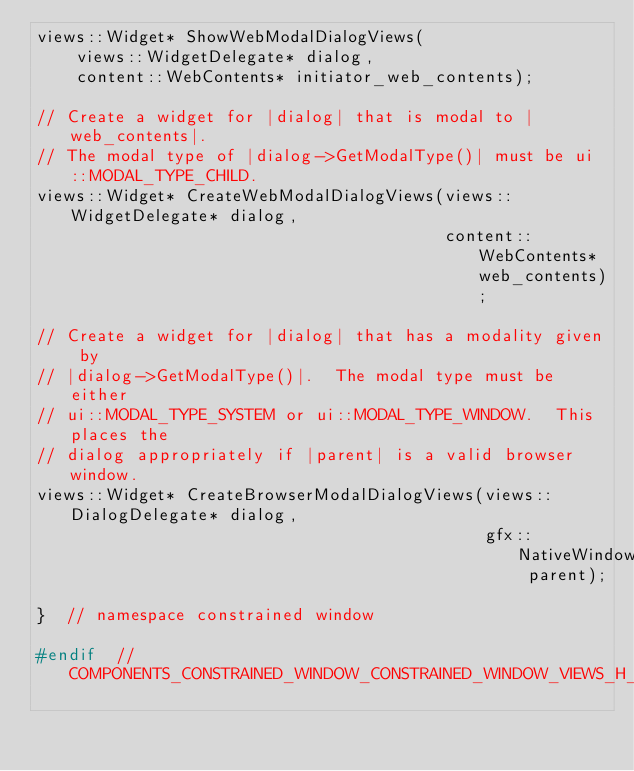<code> <loc_0><loc_0><loc_500><loc_500><_C_>views::Widget* ShowWebModalDialogViews(
    views::WidgetDelegate* dialog,
    content::WebContents* initiator_web_contents);

// Create a widget for |dialog| that is modal to |web_contents|.
// The modal type of |dialog->GetModalType()| must be ui::MODAL_TYPE_CHILD.
views::Widget* CreateWebModalDialogViews(views::WidgetDelegate* dialog,
                                         content::WebContents* web_contents);

// Create a widget for |dialog| that has a modality given by
// |dialog->GetModalType()|.  The modal type must be either
// ui::MODAL_TYPE_SYSTEM or ui::MODAL_TYPE_WINDOW.  This places the
// dialog appropriately if |parent| is a valid browser window.
views::Widget* CreateBrowserModalDialogViews(views::DialogDelegate* dialog,
                                             gfx::NativeWindow parent);

}  // namespace constrained window

#endif  // COMPONENTS_CONSTRAINED_WINDOW_CONSTRAINED_WINDOW_VIEWS_H_
</code> 